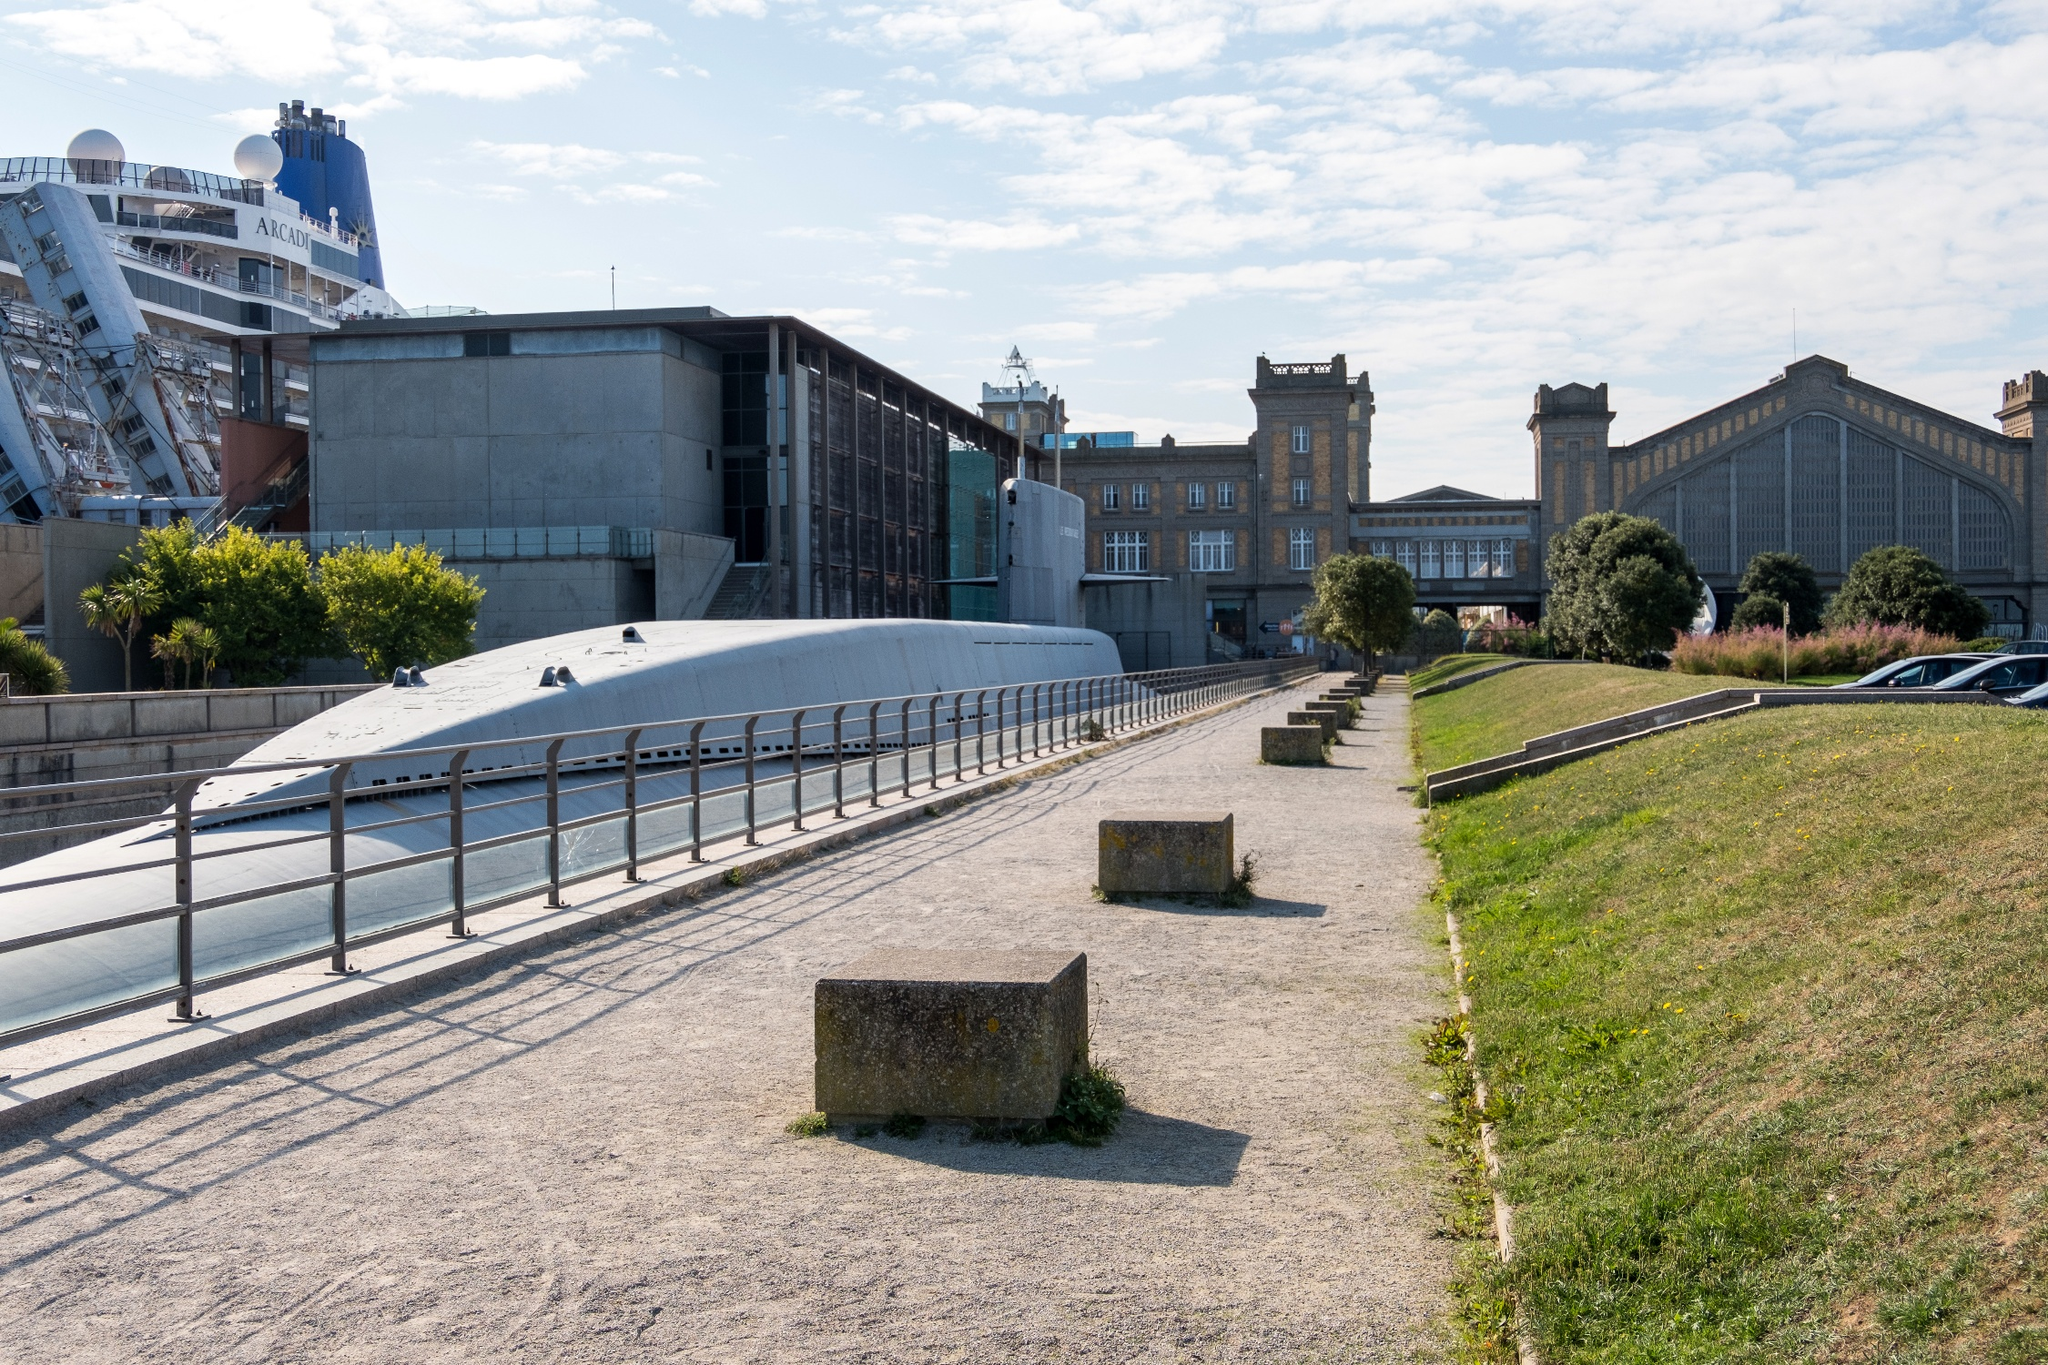If you were to write a short poetic narrative about this scene, how would it go? On a serene path where history whispers to time, 
Concrete benches rest, reflecting urban rhyme. 
The sun casts gentle shadows upon the stone, 
In this tranquil harbor, I'm not alone.
Modernity embraces tradition's art, 
In Cherbourg's heart, they never part. 
Through the lens, peace and progress conflate, 
In Normandy's embrace, they resonate. 